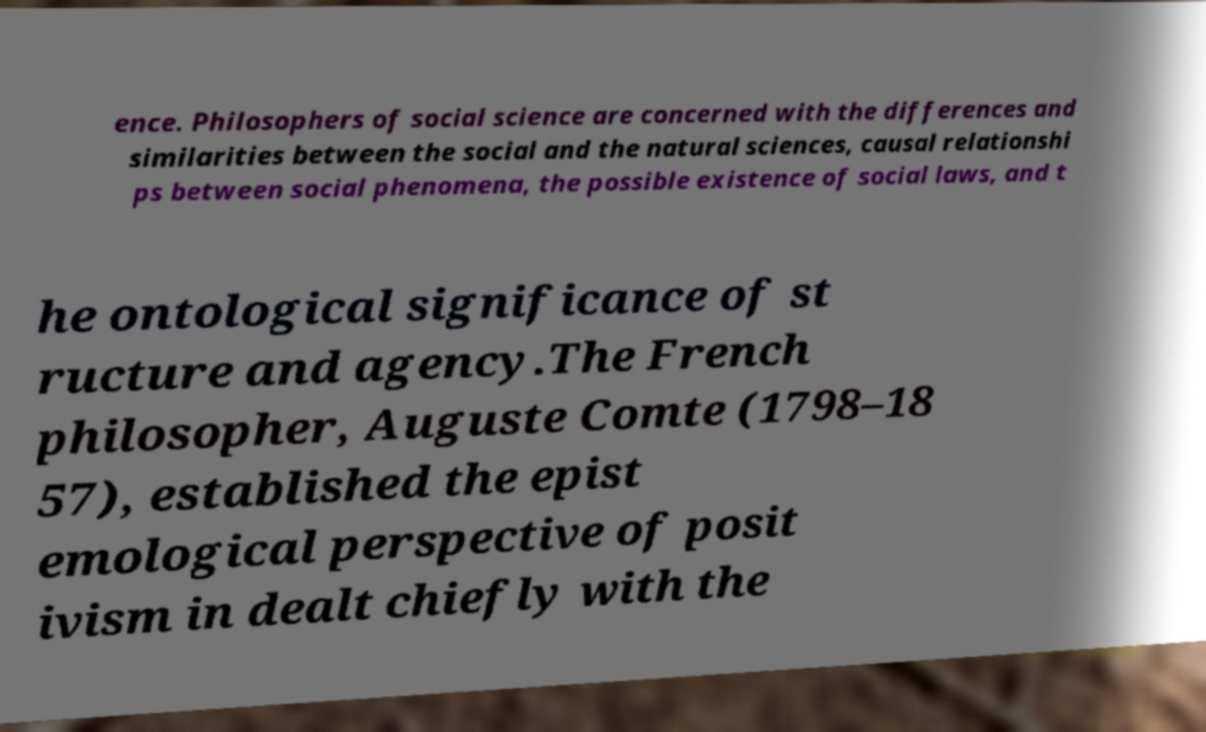Please read and relay the text visible in this image. What does it say? ence. Philosophers of social science are concerned with the differences and similarities between the social and the natural sciences, causal relationshi ps between social phenomena, the possible existence of social laws, and t he ontological significance of st ructure and agency.The French philosopher, Auguste Comte (1798–18 57), established the epist emological perspective of posit ivism in dealt chiefly with the 